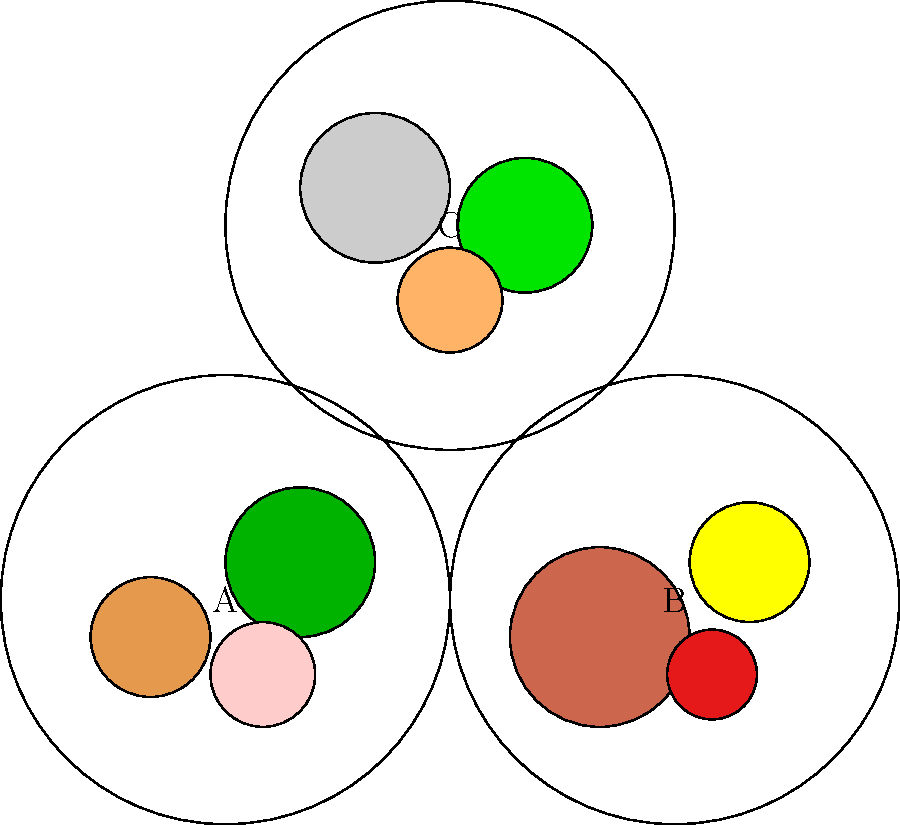As a nutritionist specializing in French cuisine, which plate combination provides the most balanced and healthiest meal according to the image? To determine the healthiest combination of French foods, we need to analyze each plate based on nutritional balance and health benefits:

1. Plate A:
   - Bread: Carbohydrates, but potentially refined
   - Salad: Vitamins, minerals, and fiber
   - Cheese: Protein and calcium, but high in saturated fat

2. Plate B:
   - Beef: High-quality protein, but also high in saturated fat
   - Potatoes: Carbohydrates and some vitamins, but high glycemic index
   - Tomatoes: Vitamins, antioxidants, and lycopene

3. Plate C:
   - Fish: Lean protein and omega-3 fatty acids
   - Broccoli: Rich in vitamins, minerals, and fiber
   - Quinoa: Complete protein, fiber, and complex carbohydrates

Plate C offers the most balanced and healthiest meal because:
1. Fish provides lean protein and heart-healthy omega-3 fatty acids.
2. Broccoli is a nutrient-dense vegetable with various vitamins, minerals, and fiber.
3. Quinoa is a complete protein source and provides complex carbohydrates and additional fiber.

This combination ensures a balance of lean protein, complex carbohydrates, and vegetables, which aligns with nutritional guidelines for a healthy meal.
Answer: Plate C 